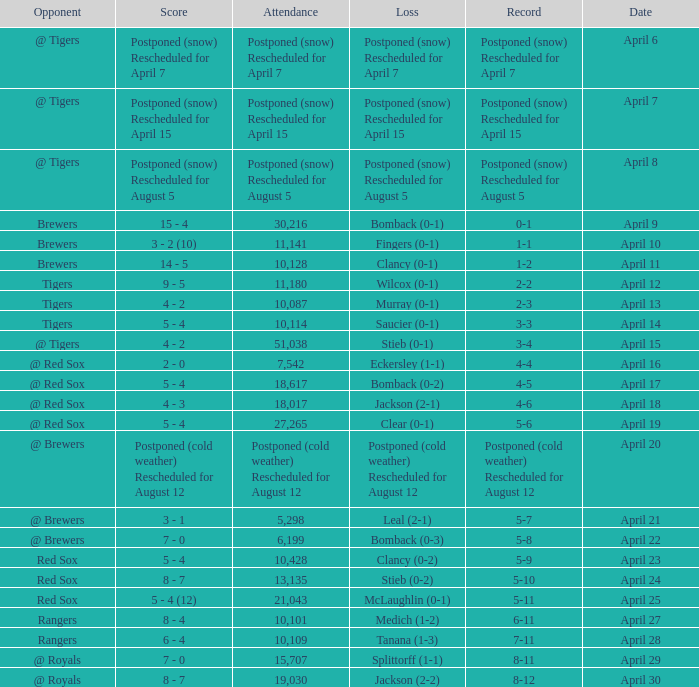What was the date for the game that had an attendance of 10,101? April 27. 